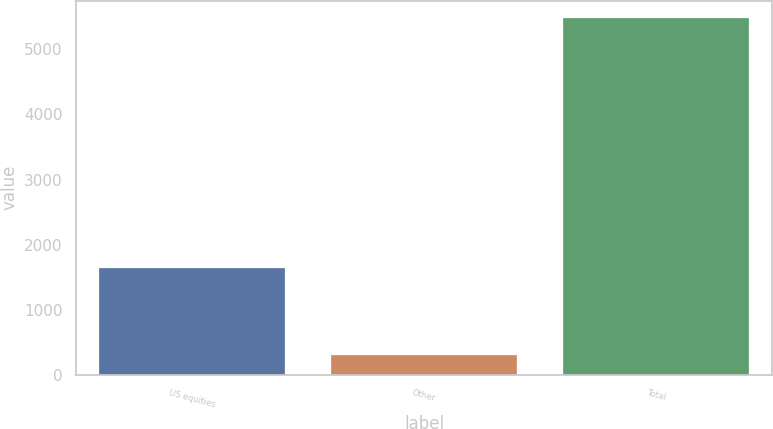<chart> <loc_0><loc_0><loc_500><loc_500><bar_chart><fcel>US equities<fcel>Other<fcel>Total<nl><fcel>1643<fcel>312<fcel>5476<nl></chart> 